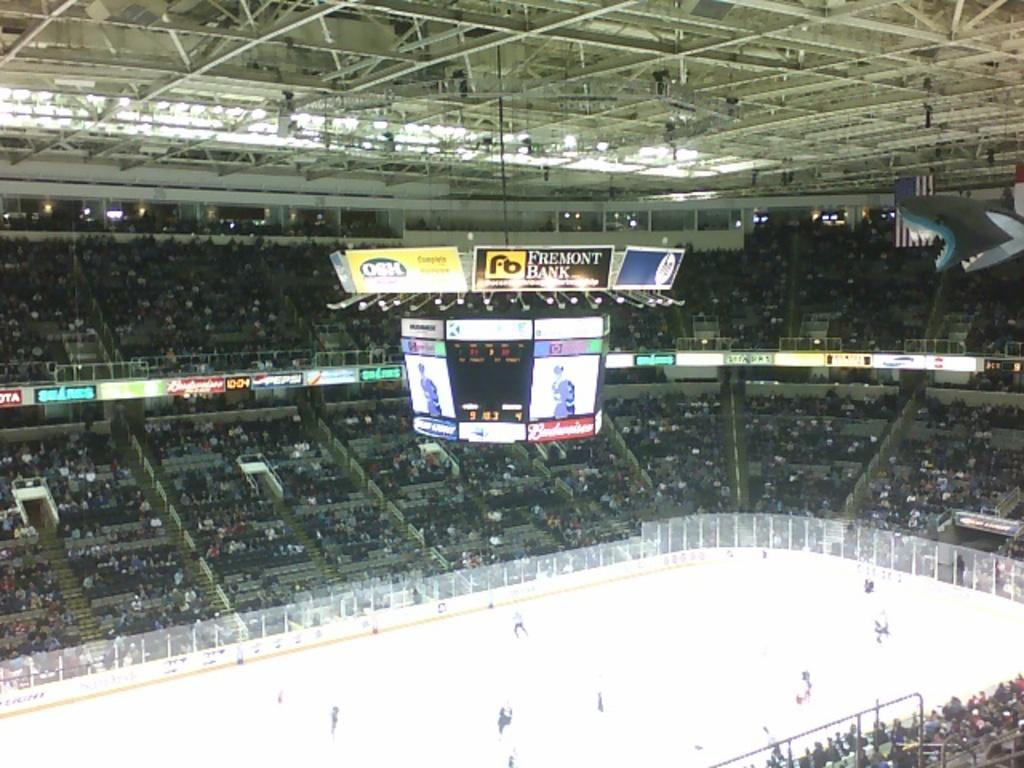<image>
Present a compact description of the photo's key features. An ice arena with the center sign saying it is sponsored by Fremont Bank. 